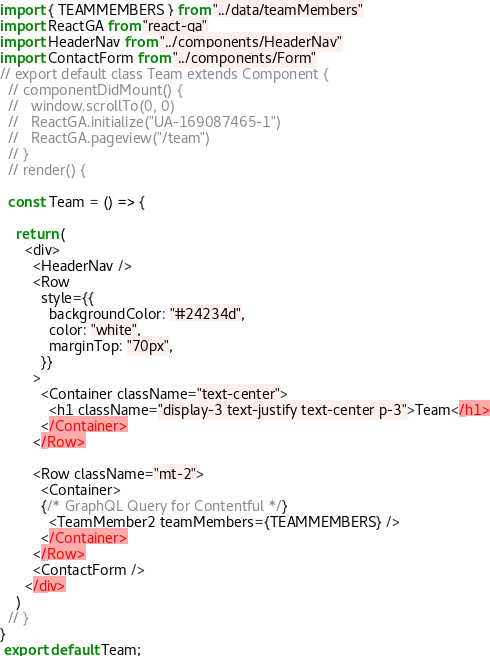<code> <loc_0><loc_0><loc_500><loc_500><_JavaScript_>import { TEAMMEMBERS } from "../data/teamMembers"
import ReactGA from "react-ga"
import HeaderNav from "../components/HeaderNav"
import ContactForm from "../components/Form"
// export default class Team extends Component {
  // componentDidMount() {
  //   window.scrollTo(0, 0)
  //   ReactGA.initialize("UA-169087465-1")
  //   ReactGA.pageview("/team")
  // }
  // render() {

  const Team = () => {
  
    return (
      <div>
        <HeaderNav />
        <Row
          style={{
            backgroundColor: "#24234d",
            color: "white",
            marginTop: "70px",
          }}
        >
          <Container className="text-center">
            <h1 className="display-3 text-justify text-center p-3">Team</h1>
          </Container>
        </Row>

        <Row className="mt-2">
          <Container>
          {/* GraphQL Query for Contentful */}
            <TeamMember2 teamMembers={TEAMMEMBERS} />
          </Container>
        </Row>
        <ContactForm />
      </div>
    )
  // }
}
 export default Team;</code> 